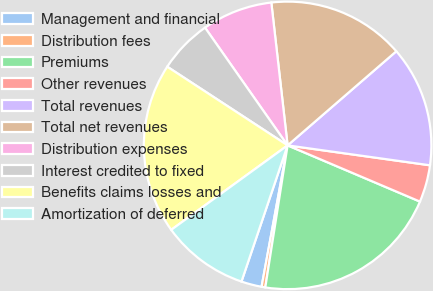<chart> <loc_0><loc_0><loc_500><loc_500><pie_chart><fcel>Management and financial<fcel>Distribution fees<fcel>Premiums<fcel>Other revenues<fcel>Total revenues<fcel>Total net revenues<fcel>Distribution expenses<fcel>Interest credited to fixed<fcel>Benefits claims losses and<fcel>Amortization of deferred<nl><fcel>2.3%<fcel>0.42%<fcel>21.09%<fcel>4.18%<fcel>13.57%<fcel>15.45%<fcel>7.93%<fcel>6.05%<fcel>19.21%<fcel>9.81%<nl></chart> 